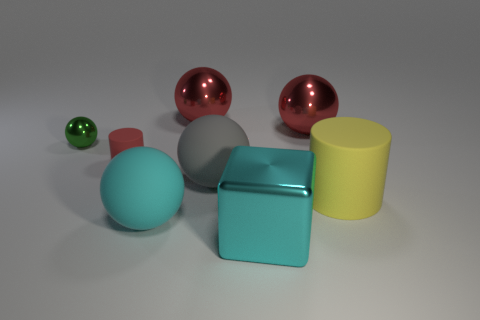Are there any other things that have the same shape as the cyan metal object?
Keep it short and to the point. No. Does the shiny sphere to the right of the cyan shiny thing have the same size as the green metallic ball?
Make the answer very short. No. What number of shiny objects are green things or big cyan blocks?
Offer a terse response. 2. Is the shape of the big cyan metal thing that is in front of the yellow rubber thing the same as  the tiny green object?
Provide a short and direct response. No. Are there more yellow rubber things that are behind the big yellow thing than tiny gray metal blocks?
Offer a terse response. No. What number of big things are both in front of the tiny cylinder and behind the large yellow matte object?
Your answer should be very brief. 1. What is the color of the cylinder on the right side of the large shiny object that is in front of the cyan ball?
Offer a very short reply. Yellow. How many tiny balls are the same color as the small matte thing?
Provide a short and direct response. 0. There is a big matte cylinder; is it the same color as the metal sphere on the left side of the red cylinder?
Make the answer very short. No. Is the number of green metal things less than the number of shiny things?
Offer a very short reply. Yes. 